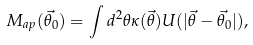Convert formula to latex. <formula><loc_0><loc_0><loc_500><loc_500>M _ { a p } ( \vec { \theta _ { 0 } } ) = \int { d ^ { 2 } \theta \kappa ( \vec { \theta } ) U ( | \vec { \theta } - \vec { \theta _ { 0 } } } | ) ,</formula> 